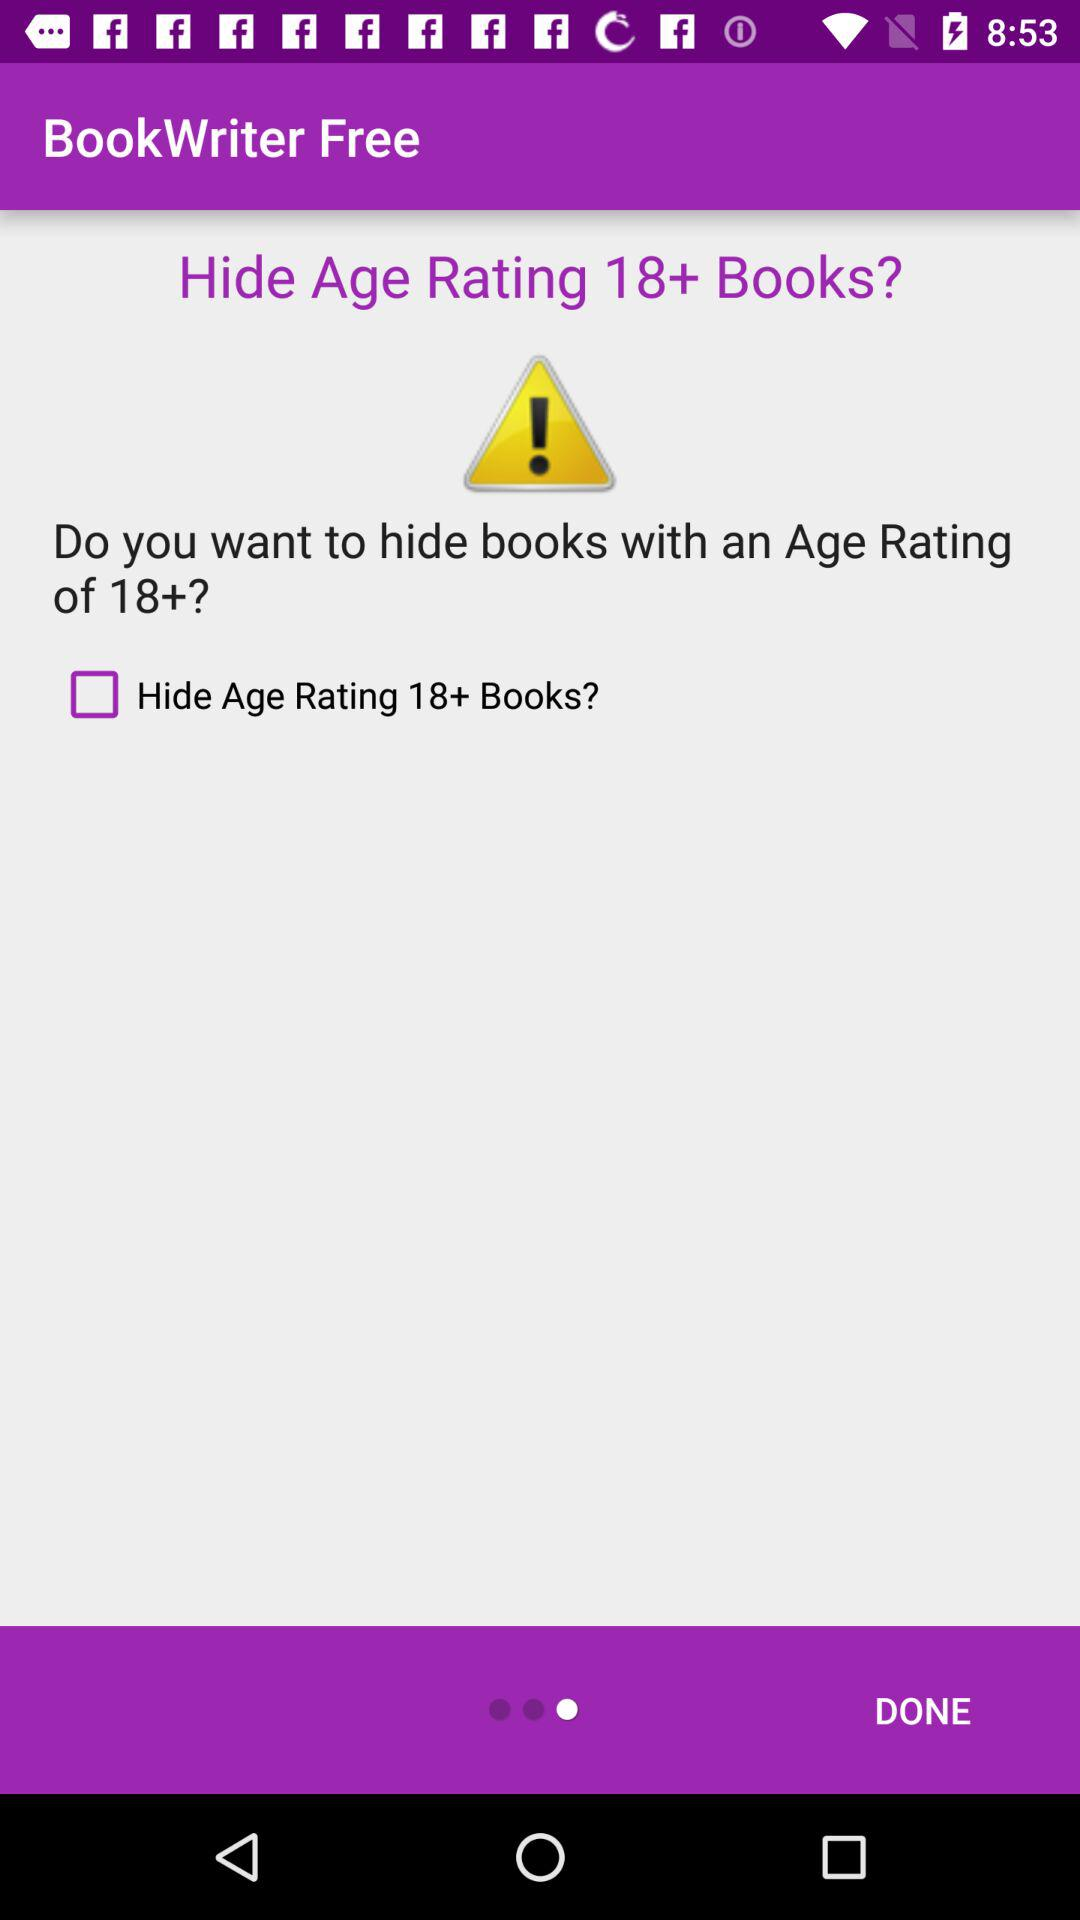What's the status of "Hide Age Rating"? The status of "Hide Age Rating" is "off". 